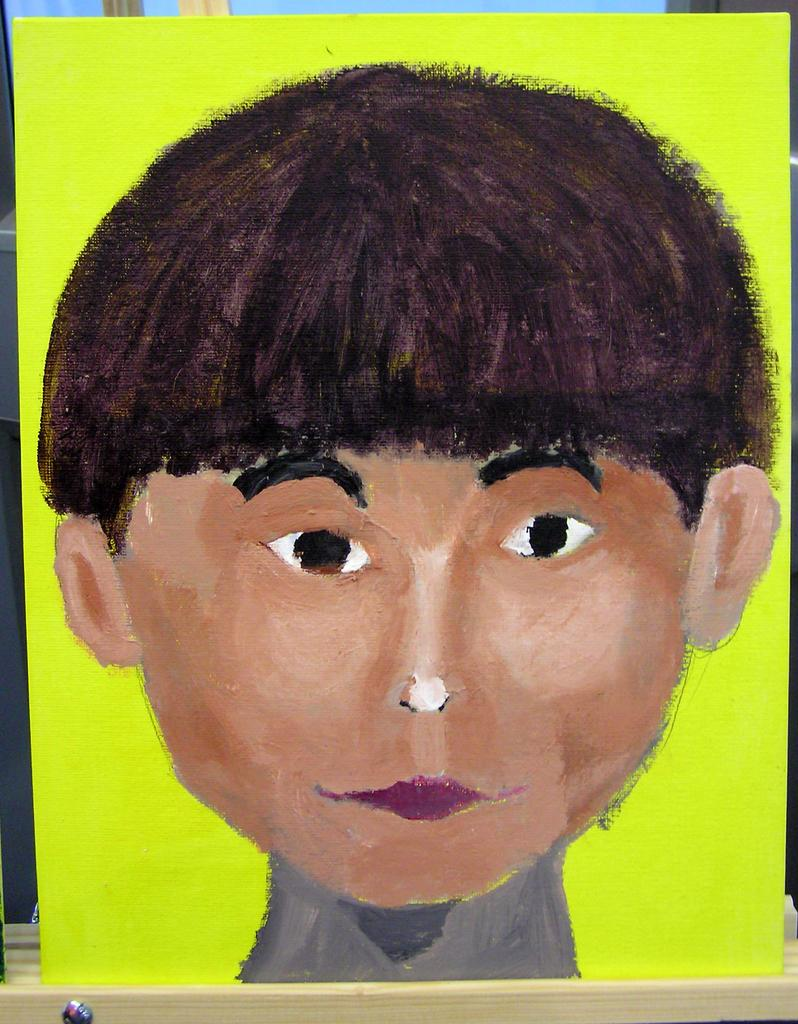What is depicted on the board in the image? There is a drawing on the board in the image. What type of moon can be seen in the drawing on the board? There is no moon present in the drawing on the board; it only contains a drawing. 